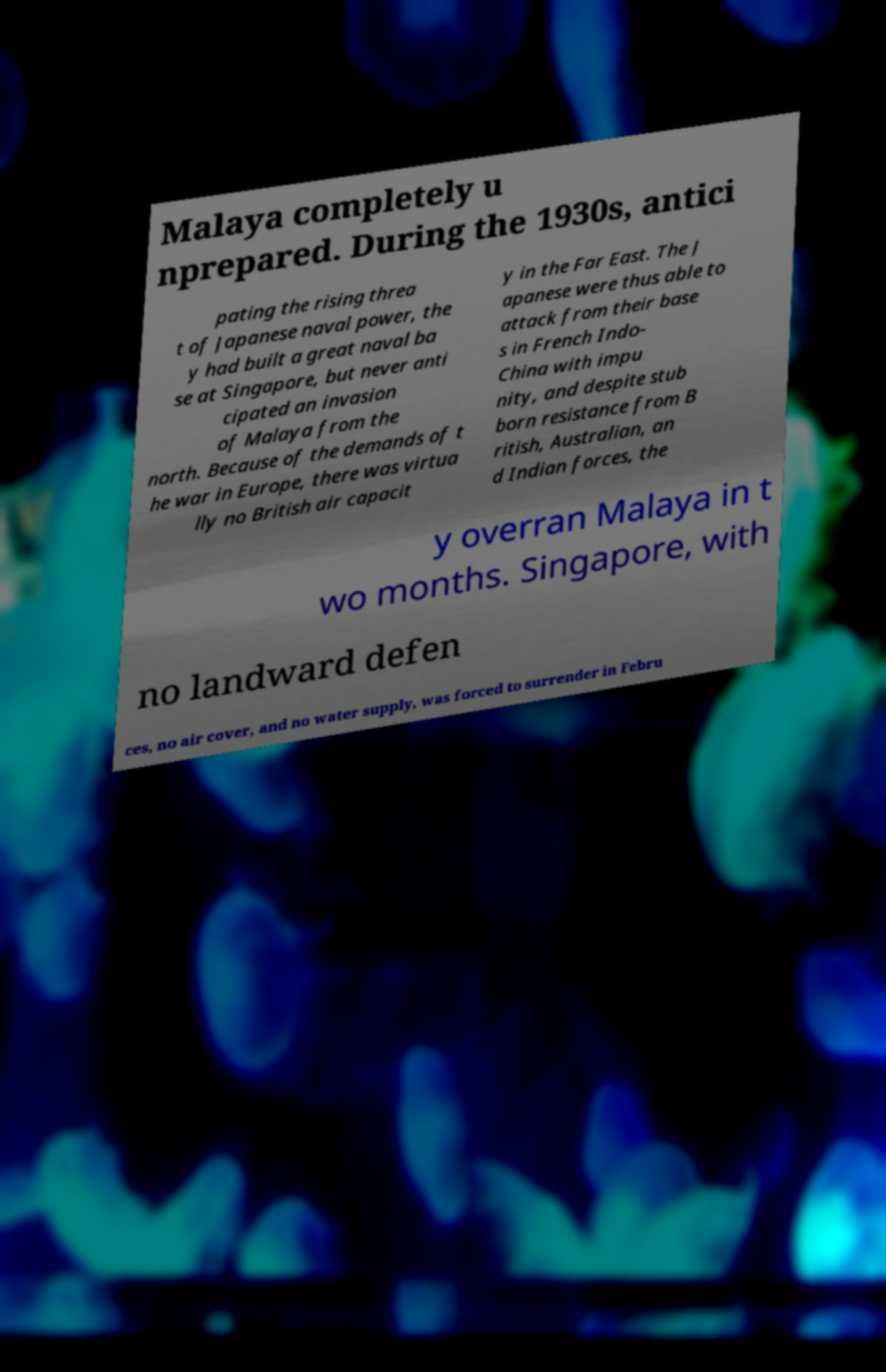Please read and relay the text visible in this image. What does it say? Malaya completely u nprepared. During the 1930s, antici pating the rising threa t of Japanese naval power, the y had built a great naval ba se at Singapore, but never anti cipated an invasion of Malaya from the north. Because of the demands of t he war in Europe, there was virtua lly no British air capacit y in the Far East. The J apanese were thus able to attack from their base s in French Indo- China with impu nity, and despite stub born resistance from B ritish, Australian, an d Indian forces, the y overran Malaya in t wo months. Singapore, with no landward defen ces, no air cover, and no water supply, was forced to surrender in Febru 